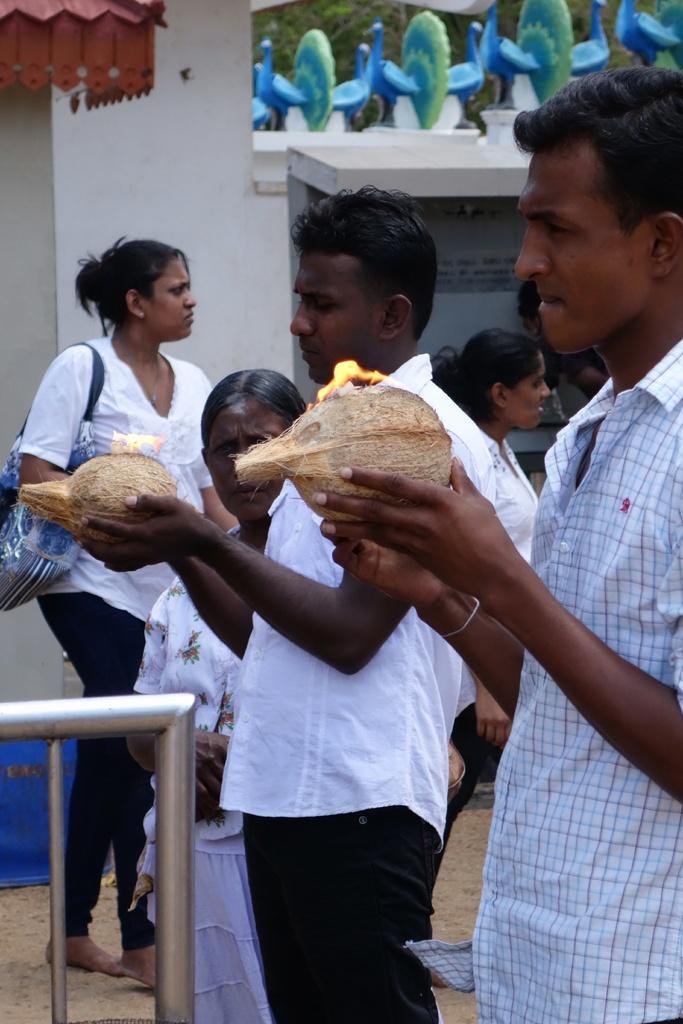Please provide a concise description of this image. There are people,these two men holding coconuts with lame and she is carrying a bag. We can see rods. In the background we can see wall and peacocks. 